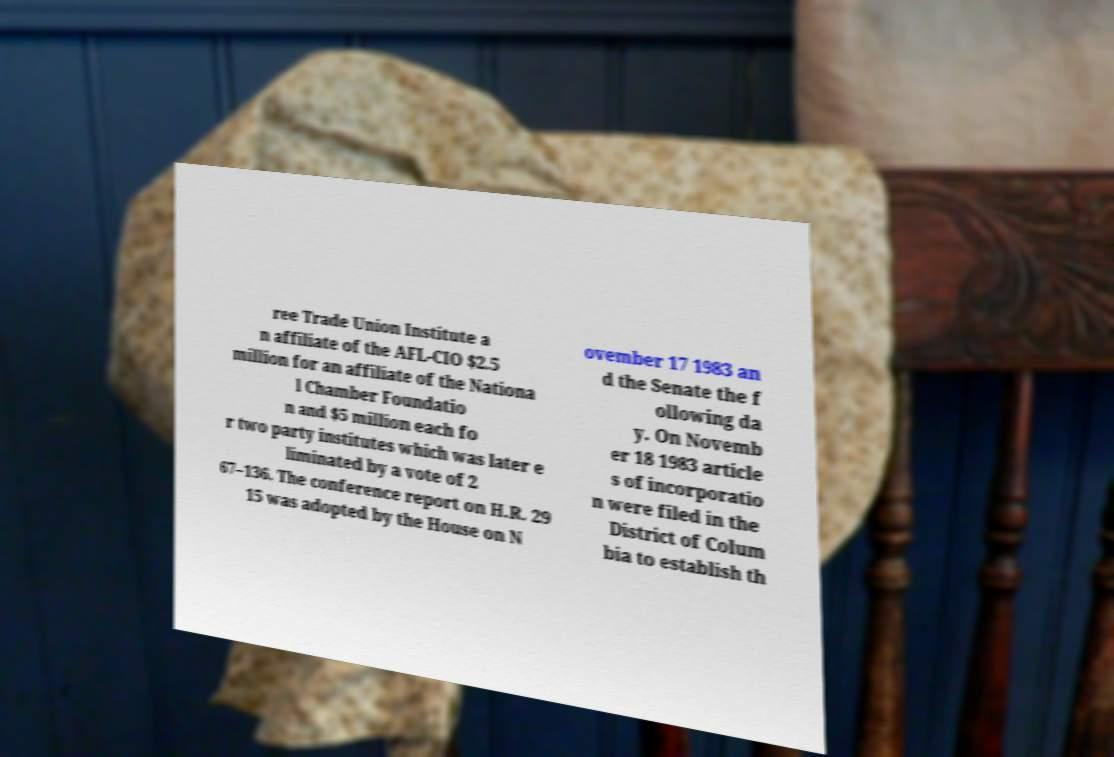Please read and relay the text visible in this image. What does it say? ree Trade Union Institute a n affiliate of the AFL-CIO $2.5 million for an affiliate of the Nationa l Chamber Foundatio n and $5 million each fo r two party institutes which was later e liminated by a vote of 2 67–136. The conference report on H.R. 29 15 was adopted by the House on N ovember 17 1983 an d the Senate the f ollowing da y. On Novemb er 18 1983 article s of incorporatio n were filed in the District of Colum bia to establish th 